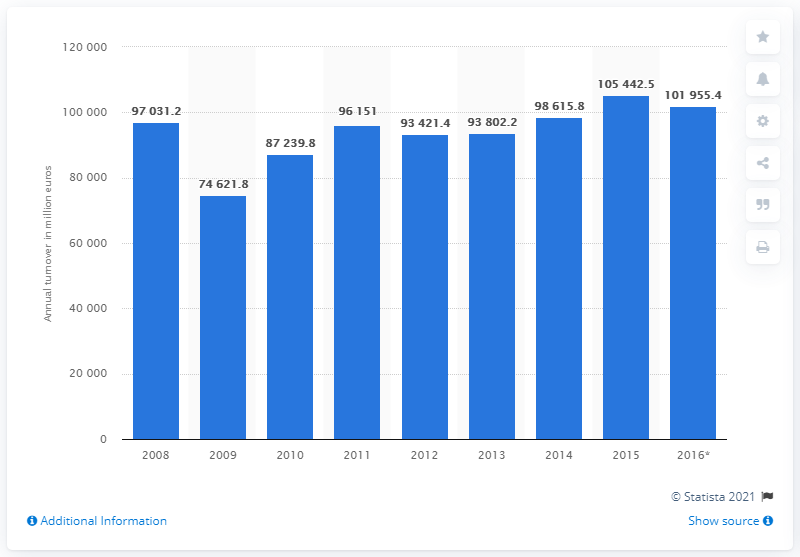Highlight a few significant elements in this photo. The turnover of the manufacturing industry in Hungary in 2015 was 105,442.5. 